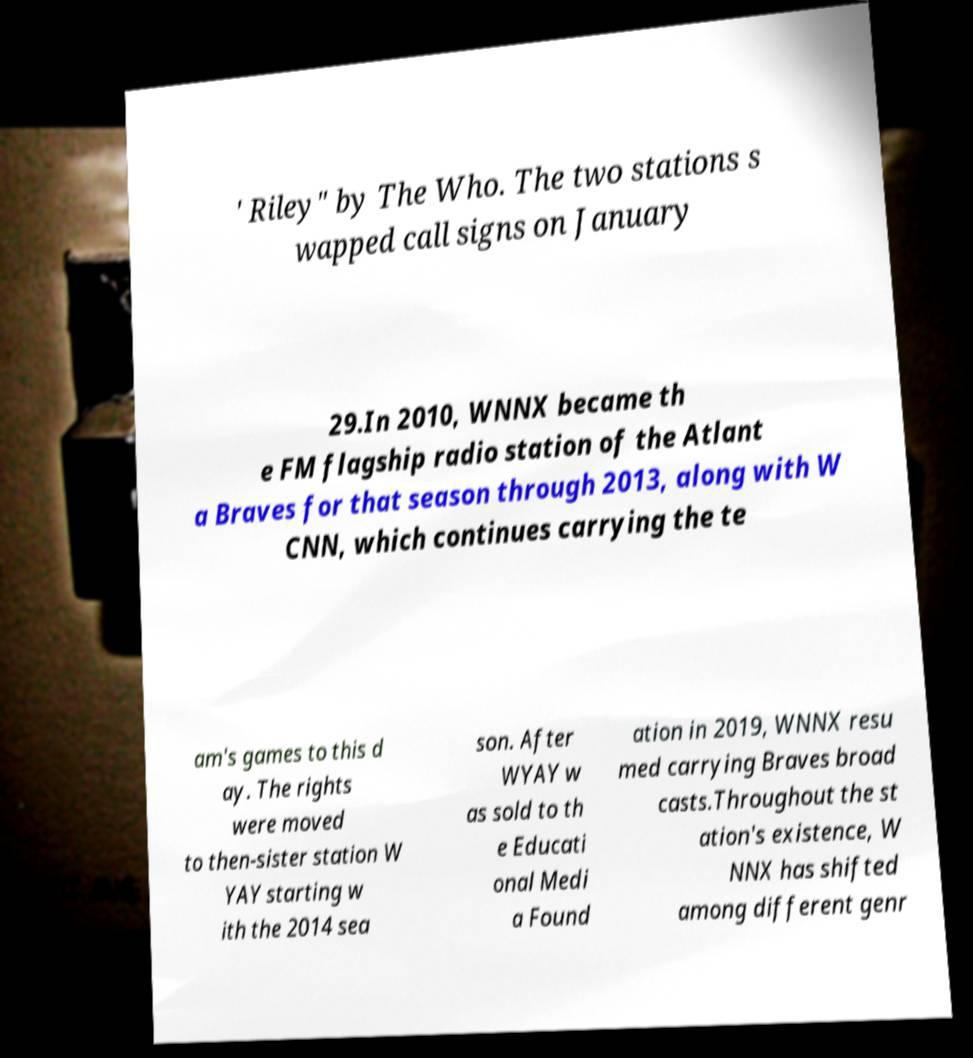For documentation purposes, I need the text within this image transcribed. Could you provide that? ' Riley" by The Who. The two stations s wapped call signs on January 29.In 2010, WNNX became th e FM flagship radio station of the Atlant a Braves for that season through 2013, along with W CNN, which continues carrying the te am's games to this d ay. The rights were moved to then-sister station W YAY starting w ith the 2014 sea son. After WYAY w as sold to th e Educati onal Medi a Found ation in 2019, WNNX resu med carrying Braves broad casts.Throughout the st ation's existence, W NNX has shifted among different genr 